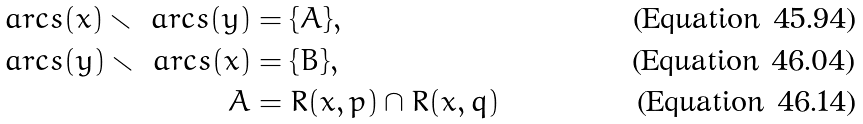Convert formula to latex. <formula><loc_0><loc_0><loc_500><loc_500>\ a r c s ( x ) \smallsetminus \ a r c s ( y ) & = \{ A \} , \\ \ a r c s ( y ) \smallsetminus \ a r c s ( x ) & = \{ B \} , \\ A & = R ( x , p ) \cap R ( x , q )</formula> 